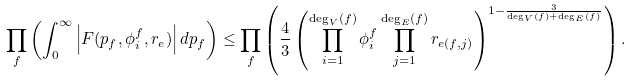Convert formula to latex. <formula><loc_0><loc_0><loc_500><loc_500>\prod _ { f } \left ( \int _ { 0 } ^ { \infty } \left | F ( p _ { f } , \phi _ { i } ^ { f } , r _ { e } ) \right | d p _ { f } \right ) \leq \prod _ { f } \left ( \frac { 4 } { 3 } \left ( \prod _ { i = 1 } ^ { \deg _ { V } ( f ) } \phi _ { i } ^ { f } \prod _ { j = 1 } ^ { \deg _ { E } ( f ) } r _ { e ( f , j ) } \right ) ^ { 1 - \frac { 3 } { \deg _ { V } ( f ) + \deg _ { E } ( f ) } } \right ) .</formula> 